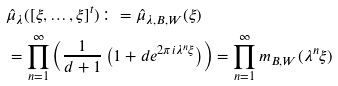<formula> <loc_0><loc_0><loc_500><loc_500>& \hat { \mu } _ { \lambda } ( [ \xi , \dots , \xi ] ^ { t } ) \colon = \hat { \mu } _ { \lambda , B , W } ( \xi ) \\ & = \prod _ { n = 1 } ^ { \infty } \left ( \frac { 1 } { d + 1 } \left ( 1 + d e ^ { 2 \pi i \lambda ^ { n } \xi } \right ) \right ) = \prod _ { n = 1 } ^ { \infty } m _ { B , W } ( \lambda ^ { n } \xi )</formula> 